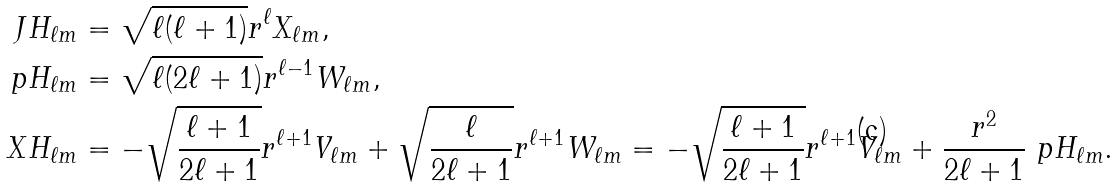Convert formula to latex. <formula><loc_0><loc_0><loc_500><loc_500>J H _ { \ell m } & = \sqrt { \ell ( \ell + 1 ) } r ^ { \ell } X _ { \ell m } , \\ \ p H _ { \ell m } & = \sqrt { \ell ( 2 \ell + 1 ) } r ^ { \ell - 1 } W _ { \ell m } , \\ X H _ { \ell m } & = - \sqrt { \frac { \ell + 1 } { 2 \ell + 1 } } r ^ { \ell + 1 } V _ { \ell m } + \sqrt { \frac { \ell } { 2 \ell + 1 } } r ^ { \ell + 1 } W _ { \ell m } = - \sqrt { \frac { \ell + 1 } { 2 \ell + 1 } } r ^ { \ell + 1 } V _ { \ell m } + \frac { r ^ { 2 } } { 2 \ell + 1 } \ p H _ { \ell m } .</formula> 